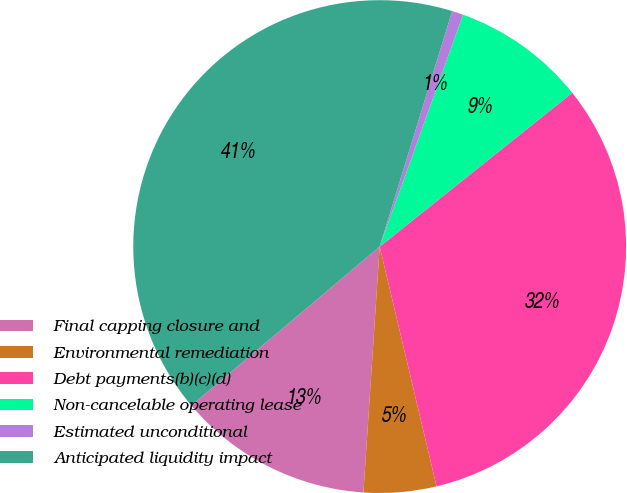Convert chart to OTSL. <chart><loc_0><loc_0><loc_500><loc_500><pie_chart><fcel>Final capping closure and<fcel>Environmental remediation<fcel>Debt payments(b)(c)(d)<fcel>Non-cancelable operating lease<fcel>Estimated unconditional<fcel>Anticipated liquidity impact<nl><fcel>12.79%<fcel>4.76%<fcel>32.02%<fcel>8.78%<fcel>0.74%<fcel>40.91%<nl></chart> 